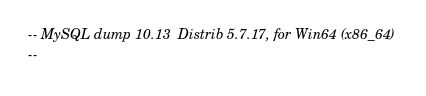Convert code to text. <code><loc_0><loc_0><loc_500><loc_500><_SQL_>-- MySQL dump 10.13  Distrib 5.7.17, for Win64 (x86_64)
--</code> 